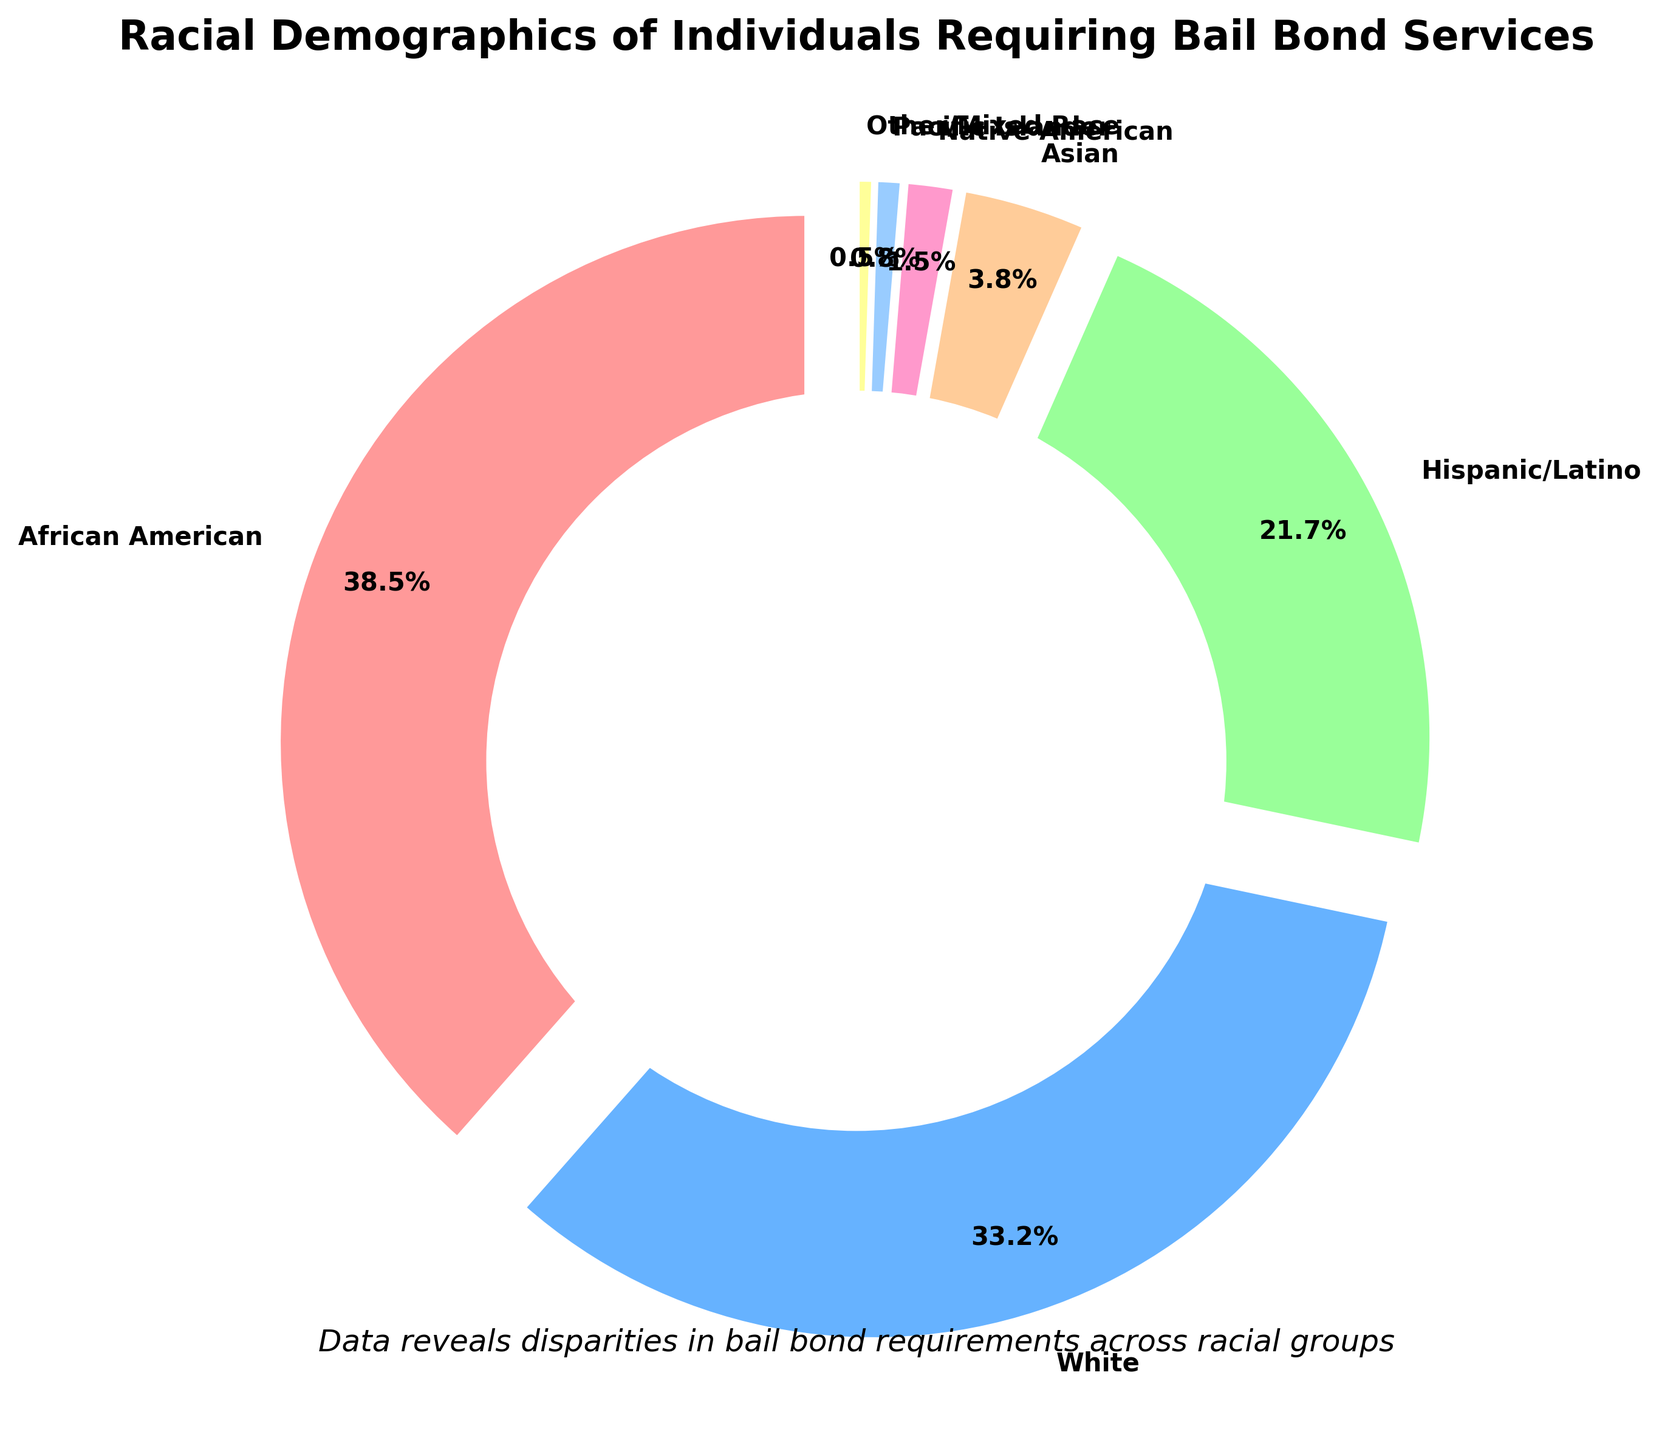What's the percentage difference between African American and Hispanic/Latino individuals requiring bail bond services? The percentage for African American individuals is 38.5%, and for Hispanic/Latino individuals, it is 21.7%. The difference is calculated as 38.5 - 21.7 = 16.8%.
Answer: 16.8% Which racial group has the smallest representation among individuals requiring bail bond services? By looking at the percentages in the figure, the group with the smallest percentage is Other/Mixed Race, with 0.5%.
Answer: Other/Mixed Race How many racial/ethnic groups have a representation less than 5% among individuals requiring bail bond services? Analyzing the figure, the groups below 5% include Asian (3.8%), Native American (1.5%), Pacific Islander (0.8%), and Other/Mixed Race (0.5%). There are 4 such groups in total.
Answer: 4 Which color is used to represent White individuals in the pie chart? By examining the colors as labeled in the pie chart, White individuals are represented by a light blue color.
Answer: Light blue What's the combined percentage of African American and White individuals requiring bail bond services? The percentage for African American individuals is 38.5% and for White individuals is 33.2%. Adding these together gives 38.5 + 33.2 = 71.7%.
Answer: 71.7% Is the percentage of Hispanic/Latino individuals greater or less than the percentage of White individuals requiring bail bond services? The percentage for Hispanic/Latino individuals is 21.7%, while for White individuals, it is 33.2%. 21.7% is less than 33.2%.
Answer: Less What is the range of the percentages shown in the pie chart? The highest percentage is 38.5% (African American), and the lowest is 0.5% (Other/Mixed Race). The range is calculated as 38.5 - 0.5 = 38.0%.
Answer: 38.0% Of the racial/ethnic groups represented, which has the fourth highest percentage, and what is it? The order from highest to lowest percentage is: African American (38.5%), White (33.2%), Hispanic/Latino (21.7%), and then Asian (3.8%). So the fourth highest percentage is Asian with 3.8%.
Answer: Asian, 3.8% What might be the sum of the percentages for the smallest three groups? The smallest three groups are Native American (1.5%), Pacific Islander (0.8%), and Other/Mixed Race (0.5%). Summing these gives 1.5 + 0.8 + 0.5 = 2.8%.
Answer: 2.8% If we group all non-White racial/ethnic categories together, what would be their total percentage? Adding the percentages: African American (38.5%), Hispanic/Latino (21.7%), Asian (3.8%), Native American (1.5%), Pacific Islander (0.8%), and Other/Mixed Race (0.5%) gives 38.5 + 21.7 + 3.8 + 1.5 + 0.8 + 0.5 = 66.8%.
Answer: 66.8% 